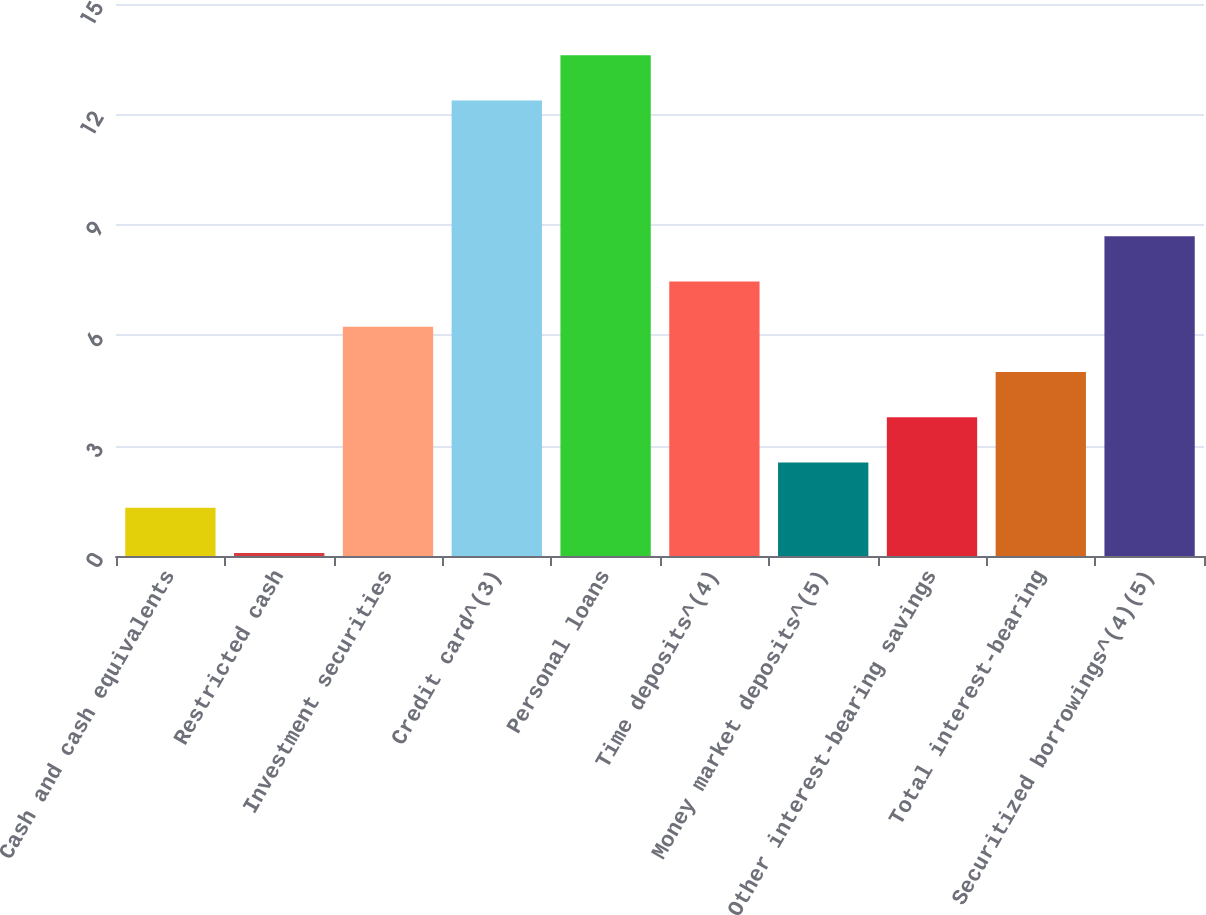<chart> <loc_0><loc_0><loc_500><loc_500><bar_chart><fcel>Cash and cash equivalents<fcel>Restricted cash<fcel>Investment securities<fcel>Credit card^(3)<fcel>Personal loans<fcel>Time deposits^(4)<fcel>Money market deposits^(5)<fcel>Other interest-bearing savings<fcel>Total interest-bearing<fcel>Securitized borrowings^(4)(5)<nl><fcel>1.31<fcel>0.08<fcel>6.23<fcel>12.38<fcel>13.61<fcel>7.46<fcel>2.54<fcel>3.77<fcel>5<fcel>8.69<nl></chart> 